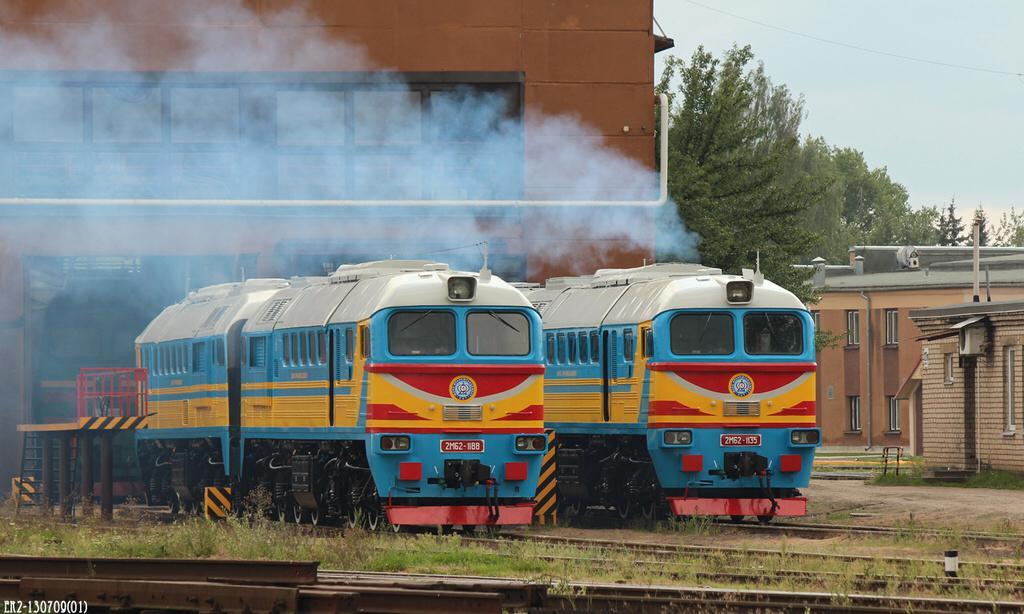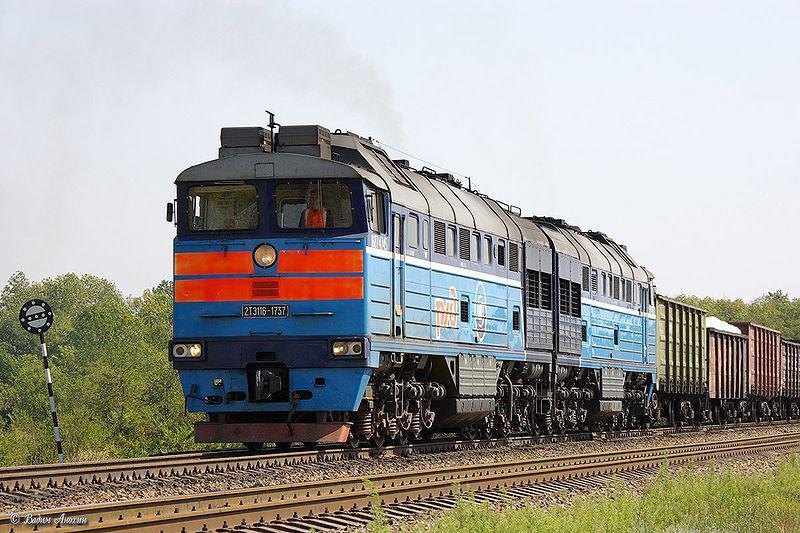The first image is the image on the left, the second image is the image on the right. Given the left and right images, does the statement "All of the trains are facing to the right." hold true? Answer yes or no. No. The first image is the image on the left, the second image is the image on the right. Examine the images to the left and right. Is the description "the right side image has a train heading to the left direction" accurate? Answer yes or no. Yes. 